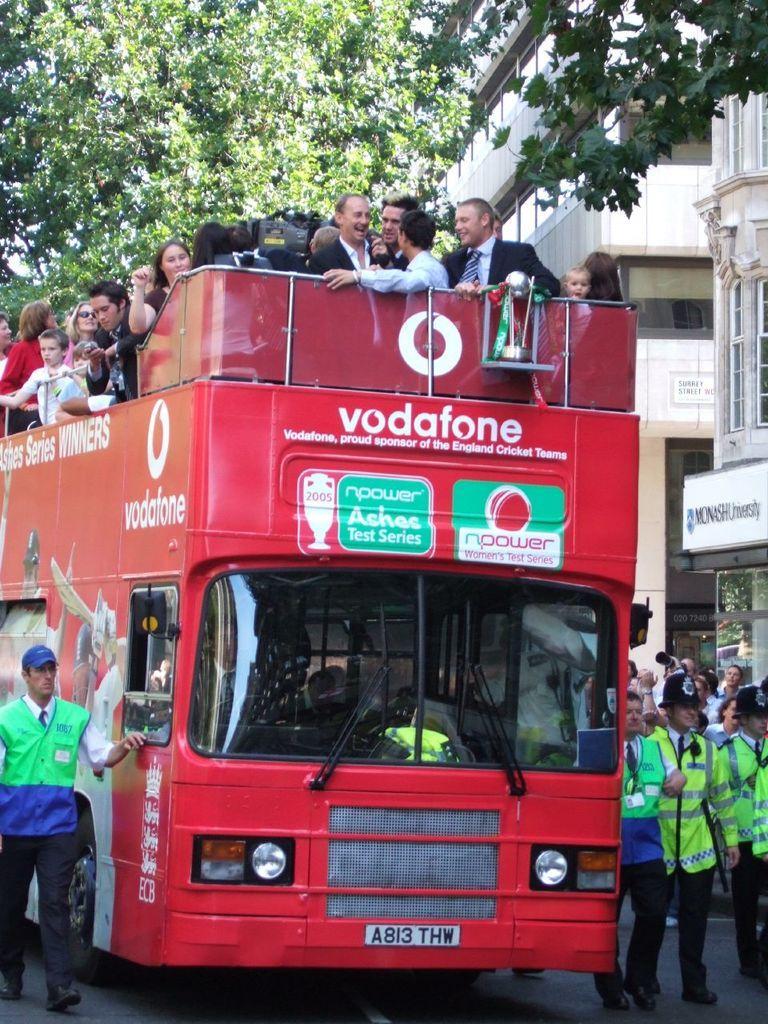In one or two sentences, can you explain what this image depicts? In the center of the image there is a red color bus. There are people in it. There are few people walking on the road. In the background of the image there are buildings, trees. 